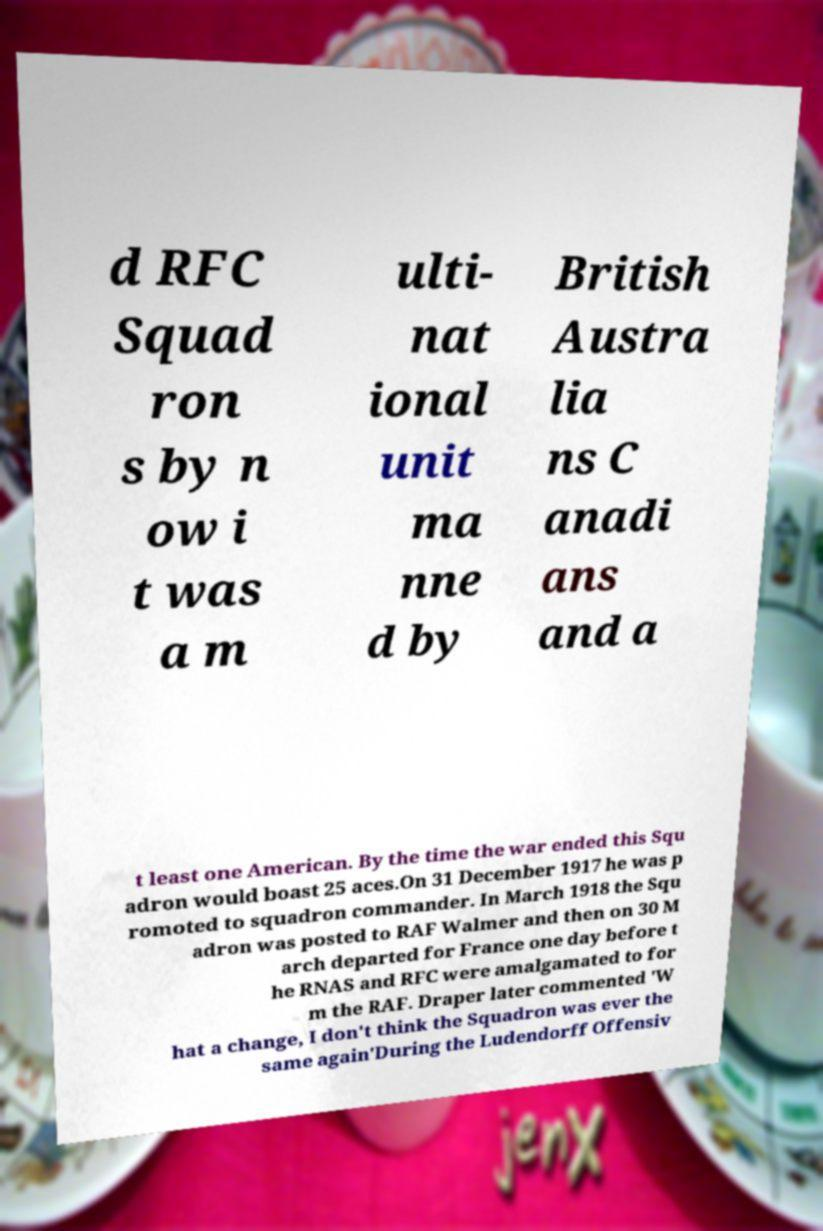Please identify and transcribe the text found in this image. d RFC Squad ron s by n ow i t was a m ulti- nat ional unit ma nne d by British Austra lia ns C anadi ans and a t least one American. By the time the war ended this Squ adron would boast 25 aces.On 31 December 1917 he was p romoted to squadron commander. In March 1918 the Squ adron was posted to RAF Walmer and then on 30 M arch departed for France one day before t he RNAS and RFC were amalgamated to for m the RAF. Draper later commented 'W hat a change, I don't think the Squadron was ever the same again'During the Ludendorff Offensiv 